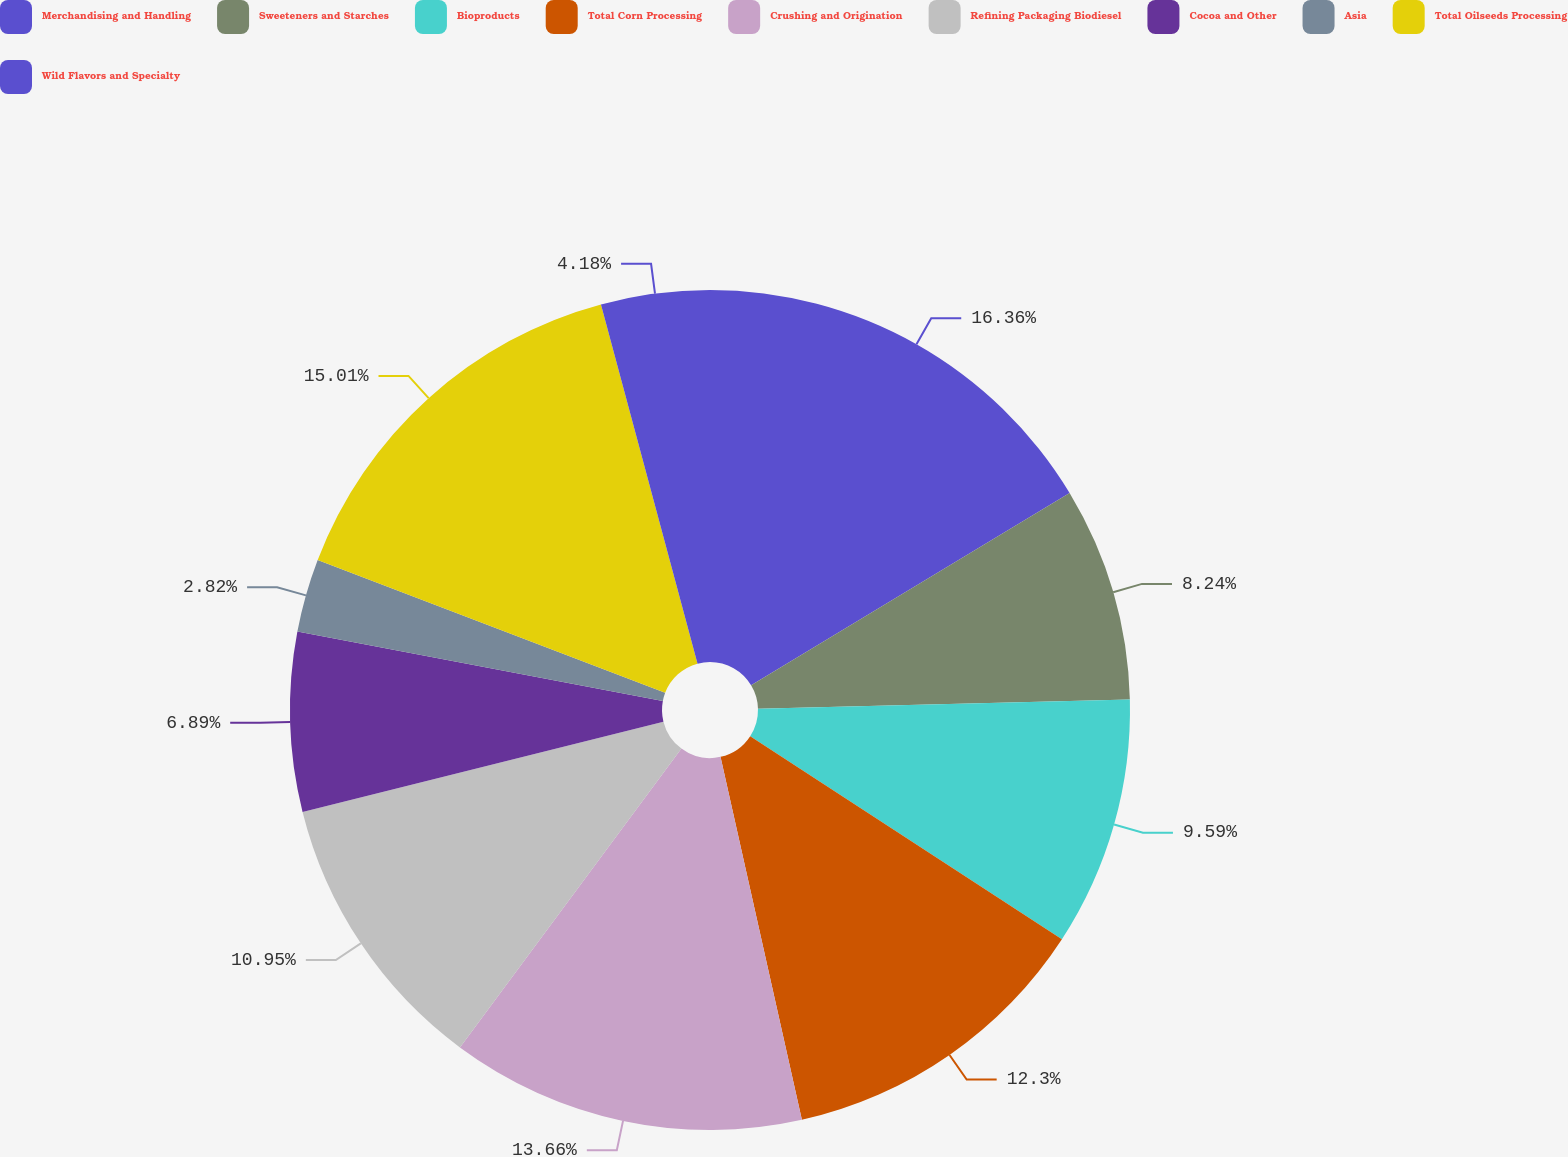Convert chart. <chart><loc_0><loc_0><loc_500><loc_500><pie_chart><fcel>Merchandising and Handling<fcel>Sweeteners and Starches<fcel>Bioproducts<fcel>Total Corn Processing<fcel>Crushing and Origination<fcel>Refining Packaging Biodiesel<fcel>Cocoa and Other<fcel>Asia<fcel>Total Oilseeds Processing<fcel>Wild Flavors and Specialty<nl><fcel>16.36%<fcel>8.24%<fcel>9.59%<fcel>12.3%<fcel>13.66%<fcel>10.95%<fcel>6.89%<fcel>2.82%<fcel>15.01%<fcel>4.18%<nl></chart> 